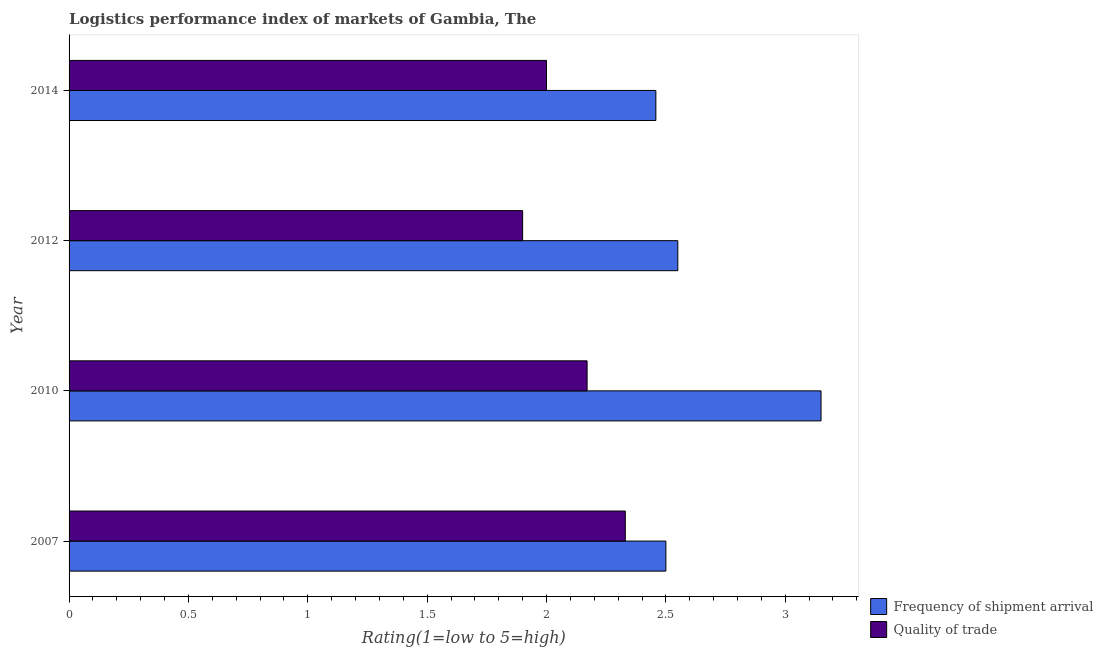How many different coloured bars are there?
Give a very brief answer. 2. What is the label of the 2nd group of bars from the top?
Offer a terse response. 2012. In how many cases, is the number of bars for a given year not equal to the number of legend labels?
Offer a terse response. 0. Across all years, what is the maximum lpi of frequency of shipment arrival?
Make the answer very short. 3.15. In which year was the lpi of frequency of shipment arrival maximum?
Your answer should be very brief. 2010. What is the total lpi of frequency of shipment arrival in the graph?
Make the answer very short. 10.66. What is the difference between the lpi of frequency of shipment arrival in 2010 and that in 2014?
Ensure brevity in your answer.  0.69. What is the difference between the lpi of frequency of shipment arrival in 2012 and the lpi quality of trade in 2007?
Provide a short and direct response. 0.22. What is the average lpi of frequency of shipment arrival per year?
Provide a short and direct response. 2.67. In the year 2010, what is the difference between the lpi quality of trade and lpi of frequency of shipment arrival?
Offer a very short reply. -0.98. In how many years, is the lpi quality of trade greater than 0.4 ?
Provide a succinct answer. 4. What is the ratio of the lpi quality of trade in 2007 to that in 2014?
Give a very brief answer. 1.17. Is the lpi quality of trade in 2010 less than that in 2012?
Give a very brief answer. No. Is the difference between the lpi quality of trade in 2012 and 2014 greater than the difference between the lpi of frequency of shipment arrival in 2012 and 2014?
Offer a very short reply. No. What is the difference between the highest and the lowest lpi of frequency of shipment arrival?
Offer a terse response. 0.69. What does the 2nd bar from the top in 2012 represents?
Your answer should be very brief. Frequency of shipment arrival. What does the 1st bar from the bottom in 2007 represents?
Provide a short and direct response. Frequency of shipment arrival. How many bars are there?
Keep it short and to the point. 8. How many years are there in the graph?
Keep it short and to the point. 4. Does the graph contain any zero values?
Provide a short and direct response. No. What is the title of the graph?
Make the answer very short. Logistics performance index of markets of Gambia, The. What is the label or title of the X-axis?
Keep it short and to the point. Rating(1=low to 5=high). What is the label or title of the Y-axis?
Provide a short and direct response. Year. What is the Rating(1=low to 5=high) of Quality of trade in 2007?
Your answer should be very brief. 2.33. What is the Rating(1=low to 5=high) in Frequency of shipment arrival in 2010?
Ensure brevity in your answer.  3.15. What is the Rating(1=low to 5=high) in Quality of trade in 2010?
Provide a succinct answer. 2.17. What is the Rating(1=low to 5=high) of Frequency of shipment arrival in 2012?
Provide a succinct answer. 2.55. What is the Rating(1=low to 5=high) of Quality of trade in 2012?
Your answer should be very brief. 1.9. What is the Rating(1=low to 5=high) of Frequency of shipment arrival in 2014?
Your response must be concise. 2.46. Across all years, what is the maximum Rating(1=low to 5=high) of Frequency of shipment arrival?
Your answer should be very brief. 3.15. Across all years, what is the maximum Rating(1=low to 5=high) of Quality of trade?
Provide a short and direct response. 2.33. Across all years, what is the minimum Rating(1=low to 5=high) in Frequency of shipment arrival?
Offer a very short reply. 2.46. What is the total Rating(1=low to 5=high) in Frequency of shipment arrival in the graph?
Your answer should be very brief. 10.66. What is the total Rating(1=low to 5=high) of Quality of trade in the graph?
Keep it short and to the point. 8.4. What is the difference between the Rating(1=low to 5=high) of Frequency of shipment arrival in 2007 and that in 2010?
Give a very brief answer. -0.65. What is the difference between the Rating(1=low to 5=high) in Quality of trade in 2007 and that in 2010?
Offer a very short reply. 0.16. What is the difference between the Rating(1=low to 5=high) of Frequency of shipment arrival in 2007 and that in 2012?
Provide a short and direct response. -0.05. What is the difference between the Rating(1=low to 5=high) of Quality of trade in 2007 and that in 2012?
Make the answer very short. 0.43. What is the difference between the Rating(1=low to 5=high) in Frequency of shipment arrival in 2007 and that in 2014?
Ensure brevity in your answer.  0.04. What is the difference between the Rating(1=low to 5=high) of Quality of trade in 2007 and that in 2014?
Your answer should be compact. 0.33. What is the difference between the Rating(1=low to 5=high) in Quality of trade in 2010 and that in 2012?
Provide a short and direct response. 0.27. What is the difference between the Rating(1=low to 5=high) of Frequency of shipment arrival in 2010 and that in 2014?
Make the answer very short. 0.69. What is the difference between the Rating(1=low to 5=high) in Quality of trade in 2010 and that in 2014?
Your response must be concise. 0.17. What is the difference between the Rating(1=low to 5=high) of Frequency of shipment arrival in 2012 and that in 2014?
Offer a very short reply. 0.09. What is the difference between the Rating(1=low to 5=high) of Frequency of shipment arrival in 2007 and the Rating(1=low to 5=high) of Quality of trade in 2010?
Your answer should be compact. 0.33. What is the difference between the Rating(1=low to 5=high) of Frequency of shipment arrival in 2010 and the Rating(1=low to 5=high) of Quality of trade in 2012?
Offer a terse response. 1.25. What is the difference between the Rating(1=low to 5=high) in Frequency of shipment arrival in 2010 and the Rating(1=low to 5=high) in Quality of trade in 2014?
Provide a short and direct response. 1.15. What is the difference between the Rating(1=low to 5=high) of Frequency of shipment arrival in 2012 and the Rating(1=low to 5=high) of Quality of trade in 2014?
Your response must be concise. 0.55. What is the average Rating(1=low to 5=high) in Frequency of shipment arrival per year?
Provide a succinct answer. 2.66. In the year 2007, what is the difference between the Rating(1=low to 5=high) in Frequency of shipment arrival and Rating(1=low to 5=high) in Quality of trade?
Make the answer very short. 0.17. In the year 2010, what is the difference between the Rating(1=low to 5=high) of Frequency of shipment arrival and Rating(1=low to 5=high) of Quality of trade?
Offer a very short reply. 0.98. In the year 2012, what is the difference between the Rating(1=low to 5=high) of Frequency of shipment arrival and Rating(1=low to 5=high) of Quality of trade?
Provide a succinct answer. 0.65. In the year 2014, what is the difference between the Rating(1=low to 5=high) in Frequency of shipment arrival and Rating(1=low to 5=high) in Quality of trade?
Your response must be concise. 0.46. What is the ratio of the Rating(1=low to 5=high) of Frequency of shipment arrival in 2007 to that in 2010?
Offer a terse response. 0.79. What is the ratio of the Rating(1=low to 5=high) in Quality of trade in 2007 to that in 2010?
Offer a very short reply. 1.07. What is the ratio of the Rating(1=low to 5=high) in Frequency of shipment arrival in 2007 to that in 2012?
Your answer should be very brief. 0.98. What is the ratio of the Rating(1=low to 5=high) in Quality of trade in 2007 to that in 2012?
Make the answer very short. 1.23. What is the ratio of the Rating(1=low to 5=high) in Frequency of shipment arrival in 2007 to that in 2014?
Provide a short and direct response. 1.02. What is the ratio of the Rating(1=low to 5=high) in Quality of trade in 2007 to that in 2014?
Your answer should be very brief. 1.17. What is the ratio of the Rating(1=low to 5=high) in Frequency of shipment arrival in 2010 to that in 2012?
Ensure brevity in your answer.  1.24. What is the ratio of the Rating(1=low to 5=high) of Quality of trade in 2010 to that in 2012?
Keep it short and to the point. 1.14. What is the ratio of the Rating(1=low to 5=high) in Frequency of shipment arrival in 2010 to that in 2014?
Your response must be concise. 1.28. What is the ratio of the Rating(1=low to 5=high) in Quality of trade in 2010 to that in 2014?
Make the answer very short. 1.08. What is the ratio of the Rating(1=low to 5=high) in Frequency of shipment arrival in 2012 to that in 2014?
Provide a short and direct response. 1.04. What is the ratio of the Rating(1=low to 5=high) of Quality of trade in 2012 to that in 2014?
Offer a very short reply. 0.95. What is the difference between the highest and the second highest Rating(1=low to 5=high) in Frequency of shipment arrival?
Your answer should be very brief. 0.6. What is the difference between the highest and the second highest Rating(1=low to 5=high) of Quality of trade?
Provide a succinct answer. 0.16. What is the difference between the highest and the lowest Rating(1=low to 5=high) in Frequency of shipment arrival?
Provide a succinct answer. 0.69. What is the difference between the highest and the lowest Rating(1=low to 5=high) of Quality of trade?
Make the answer very short. 0.43. 